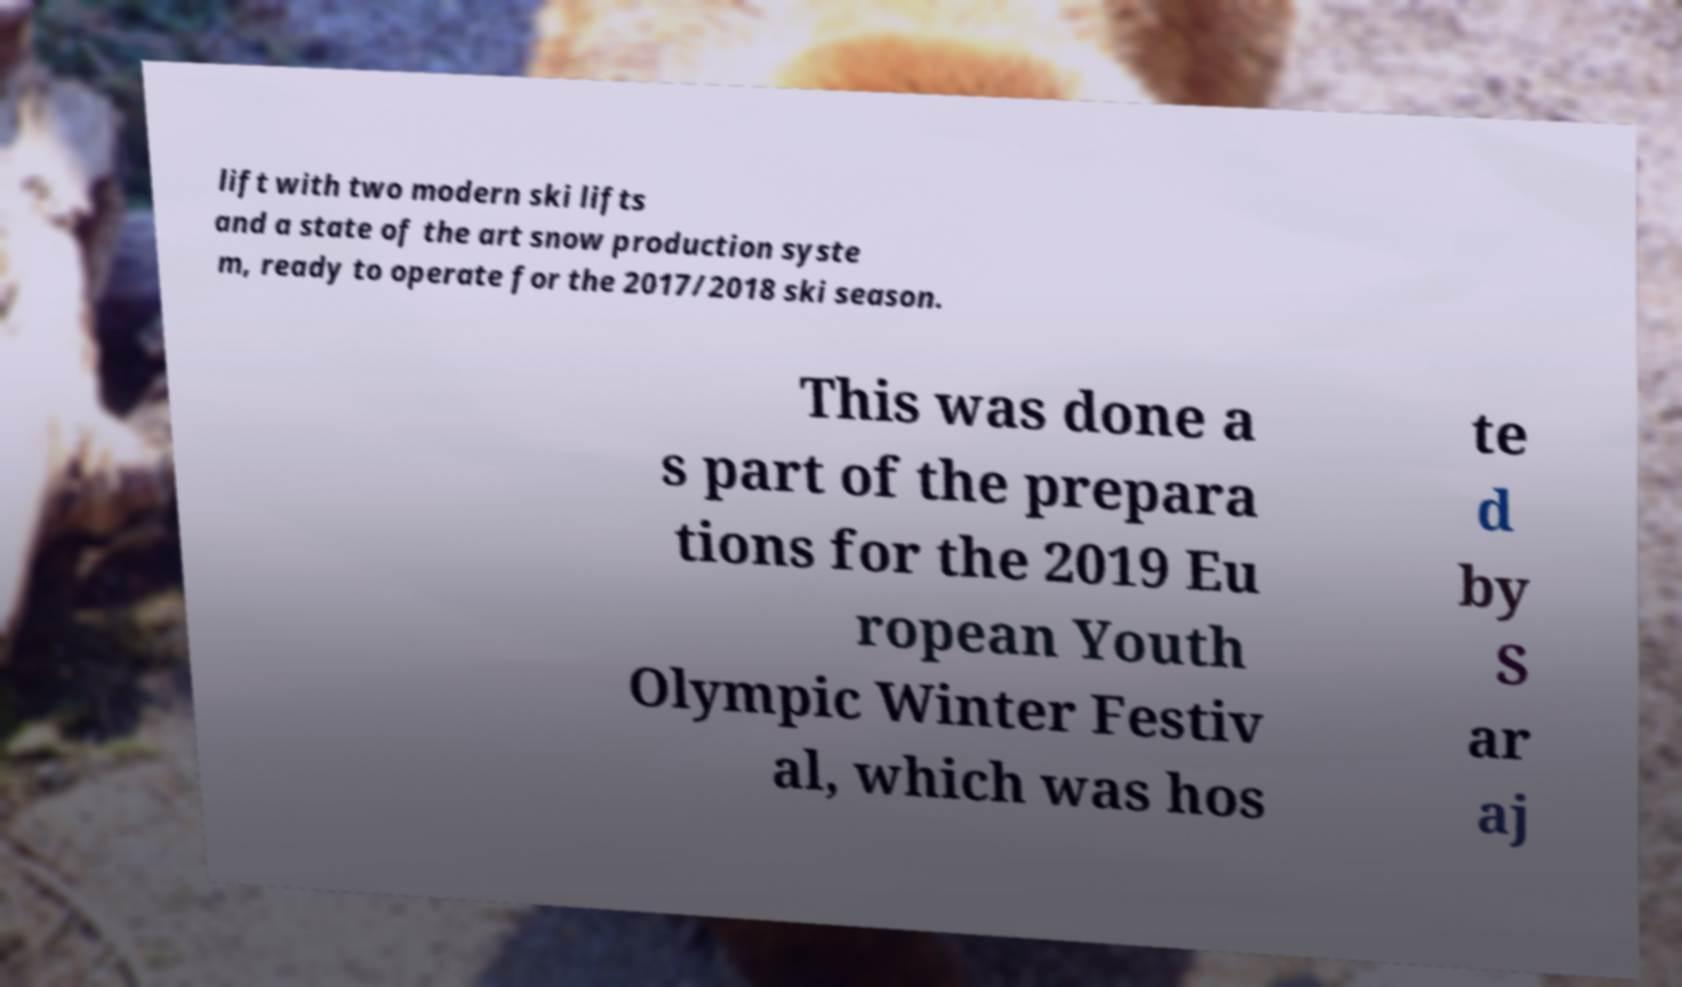There's text embedded in this image that I need extracted. Can you transcribe it verbatim? lift with two modern ski lifts and a state of the art snow production syste m, ready to operate for the 2017/2018 ski season. This was done a s part of the prepara tions for the 2019 Eu ropean Youth Olympic Winter Festiv al, which was hos te d by S ar aj 